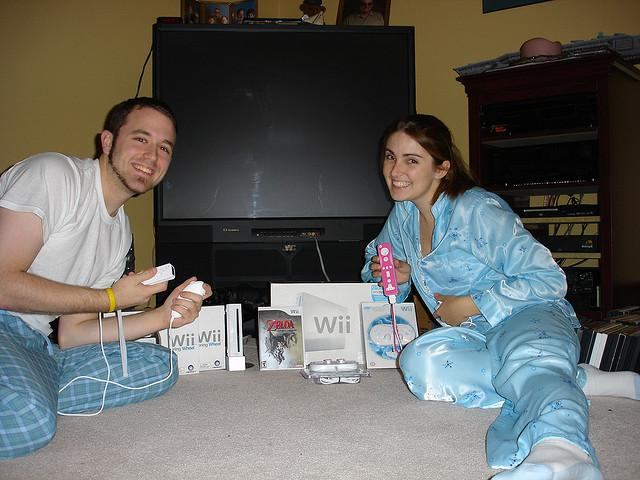Who is the main male character in that video game? Please explain your reasoning. link. The video game is zelda. zelda is the main female character. 